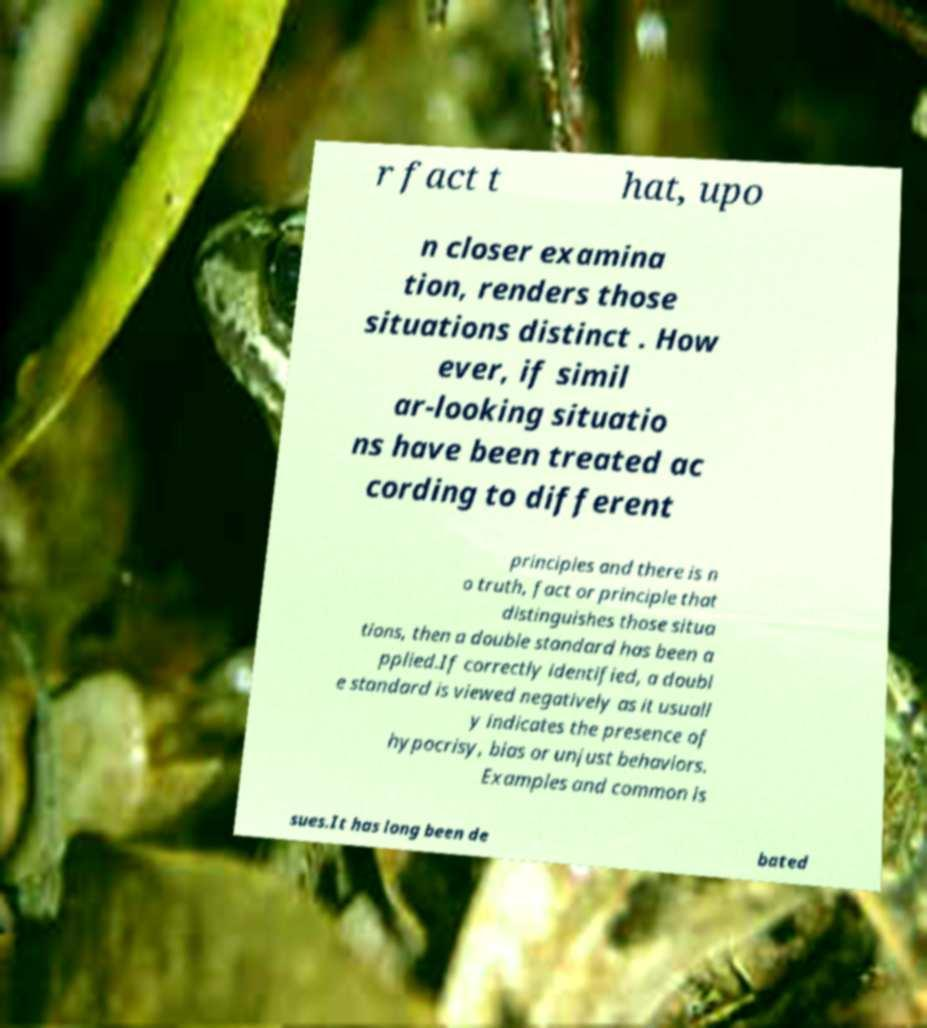What messages or text are displayed in this image? I need them in a readable, typed format. r fact t hat, upo n closer examina tion, renders those situations distinct . How ever, if simil ar-looking situatio ns have been treated ac cording to different principles and there is n o truth, fact or principle that distinguishes those situa tions, then a double standard has been a pplied.If correctly identified, a doubl e standard is viewed negatively as it usuall y indicates the presence of hypocrisy, bias or unjust behaviors. Examples and common is sues.It has long been de bated 